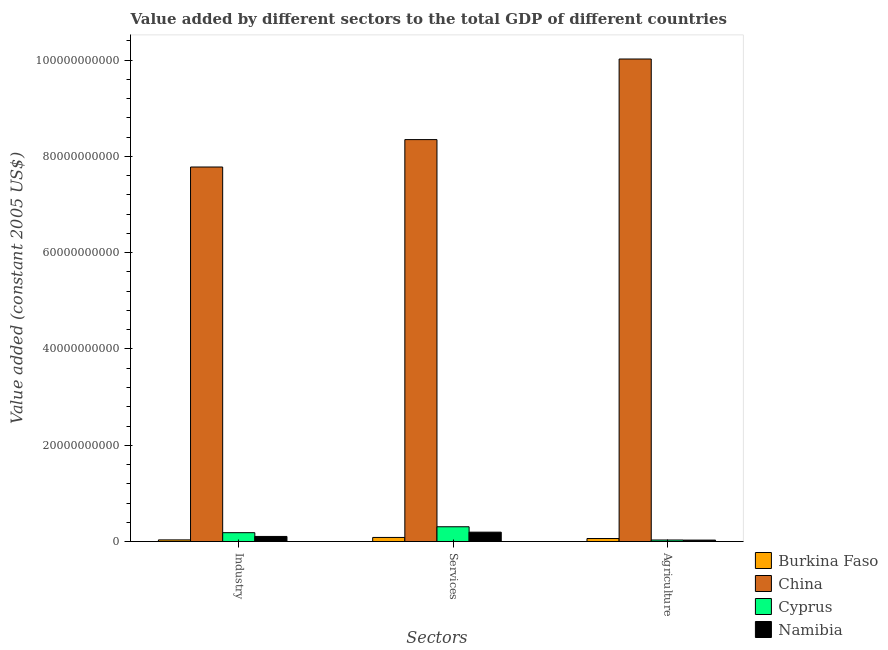How many different coloured bars are there?
Your response must be concise. 4. Are the number of bars per tick equal to the number of legend labels?
Make the answer very short. Yes. How many bars are there on the 3rd tick from the left?
Offer a very short reply. 4. How many bars are there on the 3rd tick from the right?
Make the answer very short. 4. What is the label of the 1st group of bars from the left?
Provide a short and direct response. Industry. What is the value added by services in Namibia?
Your response must be concise. 1.95e+09. Across all countries, what is the maximum value added by services?
Make the answer very short. 8.35e+1. Across all countries, what is the minimum value added by agricultural sector?
Provide a short and direct response. 3.03e+08. In which country was the value added by services minimum?
Provide a short and direct response. Burkina Faso. What is the total value added by industrial sector in the graph?
Ensure brevity in your answer.  8.11e+1. What is the difference between the value added by services in Burkina Faso and that in Namibia?
Provide a succinct answer. -1.10e+09. What is the difference between the value added by services in Burkina Faso and the value added by industrial sector in Cyprus?
Provide a succinct answer. -9.90e+08. What is the average value added by industrial sector per country?
Your response must be concise. 2.03e+1. What is the difference between the value added by industrial sector and value added by services in Namibia?
Provide a short and direct response. -8.92e+08. What is the ratio of the value added by services in Burkina Faso to that in Cyprus?
Keep it short and to the point. 0.28. Is the value added by agricultural sector in China less than that in Burkina Faso?
Your answer should be very brief. No. Is the difference between the value added by industrial sector in Burkina Faso and China greater than the difference between the value added by services in Burkina Faso and China?
Provide a succinct answer. Yes. What is the difference between the highest and the second highest value added by industrial sector?
Give a very brief answer. 7.60e+1. What is the difference between the highest and the lowest value added by industrial sector?
Keep it short and to the point. 7.75e+1. What does the 1st bar from the left in Industry represents?
Your response must be concise. Burkina Faso. What does the 3rd bar from the right in Industry represents?
Provide a short and direct response. China. Is it the case that in every country, the sum of the value added by industrial sector and value added by services is greater than the value added by agricultural sector?
Your response must be concise. Yes. How many bars are there?
Give a very brief answer. 12. Are the values on the major ticks of Y-axis written in scientific E-notation?
Your answer should be very brief. No. How many legend labels are there?
Provide a succinct answer. 4. What is the title of the graph?
Offer a terse response. Value added by different sectors to the total GDP of different countries. What is the label or title of the X-axis?
Offer a very short reply. Sectors. What is the label or title of the Y-axis?
Your answer should be very brief. Value added (constant 2005 US$). What is the Value added (constant 2005 US$) of Burkina Faso in Industry?
Your answer should be very brief. 3.46e+08. What is the Value added (constant 2005 US$) in China in Industry?
Make the answer very short. 7.78e+1. What is the Value added (constant 2005 US$) in Cyprus in Industry?
Offer a terse response. 1.84e+09. What is the Value added (constant 2005 US$) of Namibia in Industry?
Your answer should be very brief. 1.06e+09. What is the Value added (constant 2005 US$) in Burkina Faso in Services?
Provide a short and direct response. 8.55e+08. What is the Value added (constant 2005 US$) of China in Services?
Your answer should be very brief. 8.35e+1. What is the Value added (constant 2005 US$) in Cyprus in Services?
Your answer should be very brief. 3.08e+09. What is the Value added (constant 2005 US$) in Namibia in Services?
Ensure brevity in your answer.  1.95e+09. What is the Value added (constant 2005 US$) in Burkina Faso in Agriculture?
Offer a very short reply. 6.31e+08. What is the Value added (constant 2005 US$) of China in Agriculture?
Give a very brief answer. 1.00e+11. What is the Value added (constant 2005 US$) of Cyprus in Agriculture?
Offer a very short reply. 3.25e+08. What is the Value added (constant 2005 US$) in Namibia in Agriculture?
Your answer should be very brief. 3.03e+08. Across all Sectors, what is the maximum Value added (constant 2005 US$) in Burkina Faso?
Give a very brief answer. 8.55e+08. Across all Sectors, what is the maximum Value added (constant 2005 US$) of China?
Your answer should be very brief. 1.00e+11. Across all Sectors, what is the maximum Value added (constant 2005 US$) of Cyprus?
Offer a terse response. 3.08e+09. Across all Sectors, what is the maximum Value added (constant 2005 US$) of Namibia?
Make the answer very short. 1.95e+09. Across all Sectors, what is the minimum Value added (constant 2005 US$) in Burkina Faso?
Ensure brevity in your answer.  3.46e+08. Across all Sectors, what is the minimum Value added (constant 2005 US$) in China?
Provide a short and direct response. 7.78e+1. Across all Sectors, what is the minimum Value added (constant 2005 US$) in Cyprus?
Keep it short and to the point. 3.25e+08. Across all Sectors, what is the minimum Value added (constant 2005 US$) of Namibia?
Make the answer very short. 3.03e+08. What is the total Value added (constant 2005 US$) in Burkina Faso in the graph?
Offer a terse response. 1.83e+09. What is the total Value added (constant 2005 US$) of China in the graph?
Make the answer very short. 2.62e+11. What is the total Value added (constant 2005 US$) of Cyprus in the graph?
Your response must be concise. 5.25e+09. What is the total Value added (constant 2005 US$) of Namibia in the graph?
Keep it short and to the point. 3.32e+09. What is the difference between the Value added (constant 2005 US$) of Burkina Faso in Industry and that in Services?
Ensure brevity in your answer.  -5.08e+08. What is the difference between the Value added (constant 2005 US$) in China in Industry and that in Services?
Provide a succinct answer. -5.69e+09. What is the difference between the Value added (constant 2005 US$) in Cyprus in Industry and that in Services?
Make the answer very short. -1.23e+09. What is the difference between the Value added (constant 2005 US$) in Namibia in Industry and that in Services?
Make the answer very short. -8.92e+08. What is the difference between the Value added (constant 2005 US$) of Burkina Faso in Industry and that in Agriculture?
Your answer should be very brief. -2.85e+08. What is the difference between the Value added (constant 2005 US$) in China in Industry and that in Agriculture?
Your response must be concise. -2.24e+1. What is the difference between the Value added (constant 2005 US$) in Cyprus in Industry and that in Agriculture?
Your answer should be compact. 1.52e+09. What is the difference between the Value added (constant 2005 US$) of Namibia in Industry and that in Agriculture?
Offer a terse response. 7.59e+08. What is the difference between the Value added (constant 2005 US$) in Burkina Faso in Services and that in Agriculture?
Offer a terse response. 2.24e+08. What is the difference between the Value added (constant 2005 US$) in China in Services and that in Agriculture?
Your answer should be very brief. -1.67e+1. What is the difference between the Value added (constant 2005 US$) of Cyprus in Services and that in Agriculture?
Ensure brevity in your answer.  2.75e+09. What is the difference between the Value added (constant 2005 US$) of Namibia in Services and that in Agriculture?
Give a very brief answer. 1.65e+09. What is the difference between the Value added (constant 2005 US$) of Burkina Faso in Industry and the Value added (constant 2005 US$) of China in Services?
Offer a terse response. -8.31e+1. What is the difference between the Value added (constant 2005 US$) in Burkina Faso in Industry and the Value added (constant 2005 US$) in Cyprus in Services?
Your answer should be very brief. -2.73e+09. What is the difference between the Value added (constant 2005 US$) of Burkina Faso in Industry and the Value added (constant 2005 US$) of Namibia in Services?
Ensure brevity in your answer.  -1.61e+09. What is the difference between the Value added (constant 2005 US$) in China in Industry and the Value added (constant 2005 US$) in Cyprus in Services?
Offer a very short reply. 7.47e+1. What is the difference between the Value added (constant 2005 US$) of China in Industry and the Value added (constant 2005 US$) of Namibia in Services?
Your answer should be compact. 7.58e+1. What is the difference between the Value added (constant 2005 US$) in Cyprus in Industry and the Value added (constant 2005 US$) in Namibia in Services?
Make the answer very short. -1.09e+08. What is the difference between the Value added (constant 2005 US$) of Burkina Faso in Industry and the Value added (constant 2005 US$) of China in Agriculture?
Ensure brevity in your answer.  -9.99e+1. What is the difference between the Value added (constant 2005 US$) of Burkina Faso in Industry and the Value added (constant 2005 US$) of Cyprus in Agriculture?
Make the answer very short. 2.12e+07. What is the difference between the Value added (constant 2005 US$) of Burkina Faso in Industry and the Value added (constant 2005 US$) of Namibia in Agriculture?
Offer a terse response. 4.38e+07. What is the difference between the Value added (constant 2005 US$) in China in Industry and the Value added (constant 2005 US$) in Cyprus in Agriculture?
Make the answer very short. 7.75e+1. What is the difference between the Value added (constant 2005 US$) of China in Industry and the Value added (constant 2005 US$) of Namibia in Agriculture?
Your answer should be compact. 7.75e+1. What is the difference between the Value added (constant 2005 US$) of Cyprus in Industry and the Value added (constant 2005 US$) of Namibia in Agriculture?
Offer a terse response. 1.54e+09. What is the difference between the Value added (constant 2005 US$) in Burkina Faso in Services and the Value added (constant 2005 US$) in China in Agriculture?
Make the answer very short. -9.94e+1. What is the difference between the Value added (constant 2005 US$) of Burkina Faso in Services and the Value added (constant 2005 US$) of Cyprus in Agriculture?
Keep it short and to the point. 5.29e+08. What is the difference between the Value added (constant 2005 US$) in Burkina Faso in Services and the Value added (constant 2005 US$) in Namibia in Agriculture?
Provide a short and direct response. 5.52e+08. What is the difference between the Value added (constant 2005 US$) in China in Services and the Value added (constant 2005 US$) in Cyprus in Agriculture?
Your answer should be compact. 8.32e+1. What is the difference between the Value added (constant 2005 US$) in China in Services and the Value added (constant 2005 US$) in Namibia in Agriculture?
Ensure brevity in your answer.  8.32e+1. What is the difference between the Value added (constant 2005 US$) of Cyprus in Services and the Value added (constant 2005 US$) of Namibia in Agriculture?
Provide a short and direct response. 2.77e+09. What is the average Value added (constant 2005 US$) in Burkina Faso per Sectors?
Your answer should be very brief. 6.11e+08. What is the average Value added (constant 2005 US$) of China per Sectors?
Ensure brevity in your answer.  8.72e+1. What is the average Value added (constant 2005 US$) in Cyprus per Sectors?
Provide a short and direct response. 1.75e+09. What is the average Value added (constant 2005 US$) of Namibia per Sectors?
Offer a very short reply. 1.11e+09. What is the difference between the Value added (constant 2005 US$) in Burkina Faso and Value added (constant 2005 US$) in China in Industry?
Provide a succinct answer. -7.75e+1. What is the difference between the Value added (constant 2005 US$) in Burkina Faso and Value added (constant 2005 US$) in Cyprus in Industry?
Provide a short and direct response. -1.50e+09. What is the difference between the Value added (constant 2005 US$) of Burkina Faso and Value added (constant 2005 US$) of Namibia in Industry?
Ensure brevity in your answer.  -7.15e+08. What is the difference between the Value added (constant 2005 US$) of China and Value added (constant 2005 US$) of Cyprus in Industry?
Make the answer very short. 7.60e+1. What is the difference between the Value added (constant 2005 US$) of China and Value added (constant 2005 US$) of Namibia in Industry?
Provide a short and direct response. 7.67e+1. What is the difference between the Value added (constant 2005 US$) in Cyprus and Value added (constant 2005 US$) in Namibia in Industry?
Your answer should be compact. 7.83e+08. What is the difference between the Value added (constant 2005 US$) in Burkina Faso and Value added (constant 2005 US$) in China in Services?
Ensure brevity in your answer.  -8.26e+1. What is the difference between the Value added (constant 2005 US$) in Burkina Faso and Value added (constant 2005 US$) in Cyprus in Services?
Your answer should be very brief. -2.22e+09. What is the difference between the Value added (constant 2005 US$) of Burkina Faso and Value added (constant 2005 US$) of Namibia in Services?
Keep it short and to the point. -1.10e+09. What is the difference between the Value added (constant 2005 US$) of China and Value added (constant 2005 US$) of Cyprus in Services?
Your answer should be compact. 8.04e+1. What is the difference between the Value added (constant 2005 US$) in China and Value added (constant 2005 US$) in Namibia in Services?
Your answer should be very brief. 8.15e+1. What is the difference between the Value added (constant 2005 US$) of Cyprus and Value added (constant 2005 US$) of Namibia in Services?
Offer a terse response. 1.12e+09. What is the difference between the Value added (constant 2005 US$) in Burkina Faso and Value added (constant 2005 US$) in China in Agriculture?
Provide a short and direct response. -9.96e+1. What is the difference between the Value added (constant 2005 US$) in Burkina Faso and Value added (constant 2005 US$) in Cyprus in Agriculture?
Offer a very short reply. 3.06e+08. What is the difference between the Value added (constant 2005 US$) of Burkina Faso and Value added (constant 2005 US$) of Namibia in Agriculture?
Your answer should be compact. 3.28e+08. What is the difference between the Value added (constant 2005 US$) in China and Value added (constant 2005 US$) in Cyprus in Agriculture?
Provide a short and direct response. 9.99e+1. What is the difference between the Value added (constant 2005 US$) of China and Value added (constant 2005 US$) of Namibia in Agriculture?
Ensure brevity in your answer.  9.99e+1. What is the difference between the Value added (constant 2005 US$) of Cyprus and Value added (constant 2005 US$) of Namibia in Agriculture?
Your answer should be compact. 2.26e+07. What is the ratio of the Value added (constant 2005 US$) in Burkina Faso in Industry to that in Services?
Make the answer very short. 0.41. What is the ratio of the Value added (constant 2005 US$) of China in Industry to that in Services?
Ensure brevity in your answer.  0.93. What is the ratio of the Value added (constant 2005 US$) in Cyprus in Industry to that in Services?
Keep it short and to the point. 0.6. What is the ratio of the Value added (constant 2005 US$) in Namibia in Industry to that in Services?
Your answer should be compact. 0.54. What is the ratio of the Value added (constant 2005 US$) of Burkina Faso in Industry to that in Agriculture?
Your answer should be compact. 0.55. What is the ratio of the Value added (constant 2005 US$) in China in Industry to that in Agriculture?
Offer a terse response. 0.78. What is the ratio of the Value added (constant 2005 US$) in Cyprus in Industry to that in Agriculture?
Provide a short and direct response. 5.67. What is the ratio of the Value added (constant 2005 US$) in Namibia in Industry to that in Agriculture?
Ensure brevity in your answer.  3.51. What is the ratio of the Value added (constant 2005 US$) in Burkina Faso in Services to that in Agriculture?
Your answer should be very brief. 1.35. What is the ratio of the Value added (constant 2005 US$) of China in Services to that in Agriculture?
Your answer should be compact. 0.83. What is the ratio of the Value added (constant 2005 US$) in Cyprus in Services to that in Agriculture?
Provide a succinct answer. 9.46. What is the ratio of the Value added (constant 2005 US$) in Namibia in Services to that in Agriculture?
Provide a succinct answer. 6.46. What is the difference between the highest and the second highest Value added (constant 2005 US$) in Burkina Faso?
Ensure brevity in your answer.  2.24e+08. What is the difference between the highest and the second highest Value added (constant 2005 US$) of China?
Your answer should be very brief. 1.67e+1. What is the difference between the highest and the second highest Value added (constant 2005 US$) in Cyprus?
Make the answer very short. 1.23e+09. What is the difference between the highest and the second highest Value added (constant 2005 US$) in Namibia?
Ensure brevity in your answer.  8.92e+08. What is the difference between the highest and the lowest Value added (constant 2005 US$) in Burkina Faso?
Your answer should be compact. 5.08e+08. What is the difference between the highest and the lowest Value added (constant 2005 US$) in China?
Keep it short and to the point. 2.24e+1. What is the difference between the highest and the lowest Value added (constant 2005 US$) in Cyprus?
Your answer should be very brief. 2.75e+09. What is the difference between the highest and the lowest Value added (constant 2005 US$) in Namibia?
Ensure brevity in your answer.  1.65e+09. 